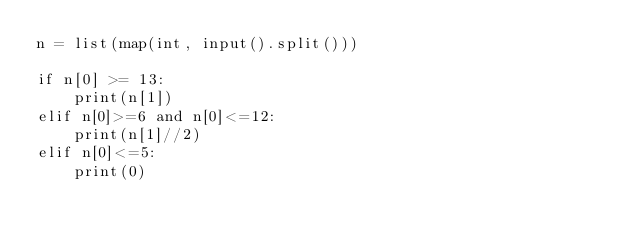Convert code to text. <code><loc_0><loc_0><loc_500><loc_500><_Python_>n = list(map(int, input().split()))

if n[0] >= 13:
    print(n[1])
elif n[0]>=6 and n[0]<=12:
    print(n[1]//2)
elif n[0]<=5:
    print(0)</code> 